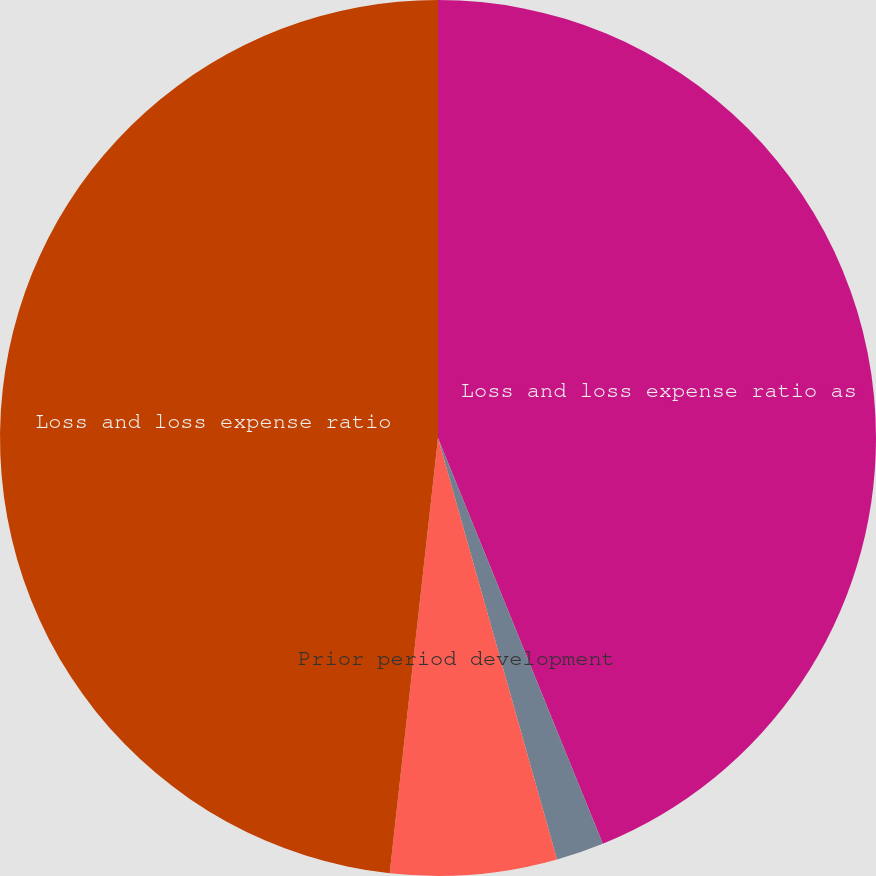<chart> <loc_0><loc_0><loc_500><loc_500><pie_chart><fcel>Loss and loss expense ratio as<fcel>Catastrophe losses<fcel>Prior period development<fcel>Loss and loss expense ratio<nl><fcel>43.86%<fcel>1.76%<fcel>6.14%<fcel>48.24%<nl></chart> 